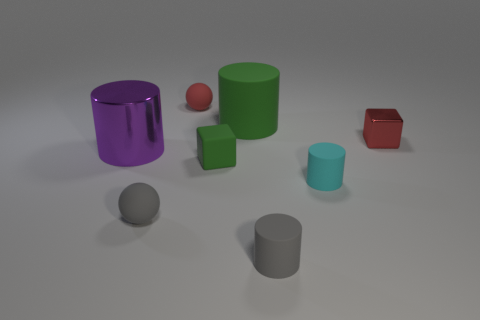Subtract 1 cylinders. How many cylinders are left? 3 Add 1 shiny things. How many objects exist? 9 Subtract all blocks. How many objects are left? 6 Subtract all tiny blocks. Subtract all purple metal cylinders. How many objects are left? 5 Add 5 small cyan rubber objects. How many small cyan rubber objects are left? 6 Add 2 brown rubber balls. How many brown rubber balls exist? 2 Subtract 1 gray balls. How many objects are left? 7 